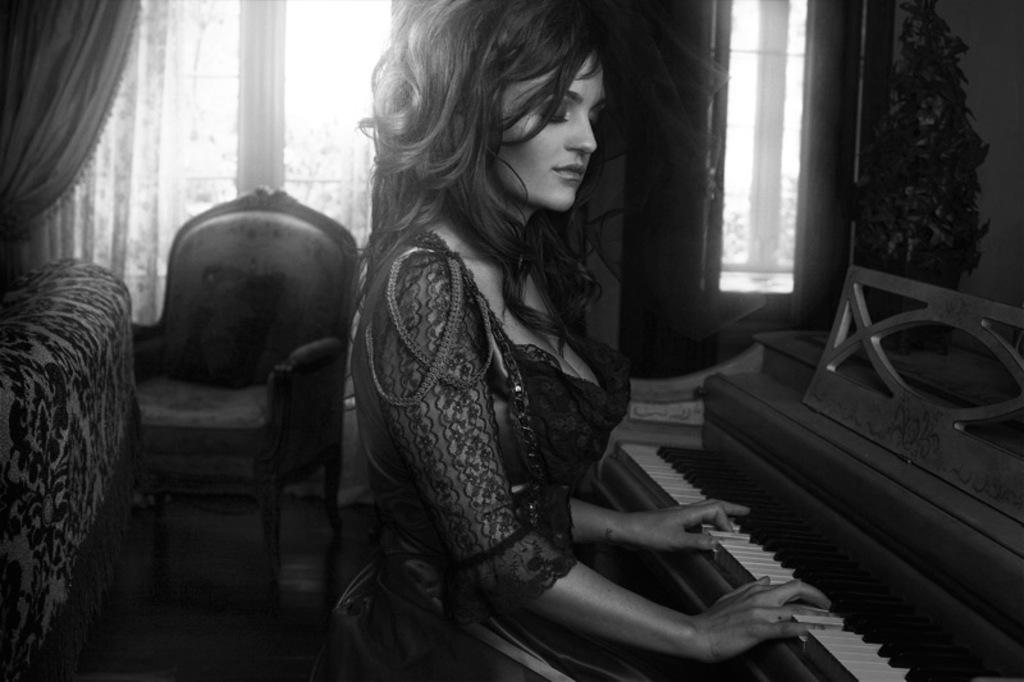Who is the main subject in the image? There is a girl in the image. What is the girl doing in the image? The girl is playing the piano. Where is the piano located in relation to the girl? The piano is in front of the girl. What can be seen in the background of the image? There is a chair and a window in the background of the image. What type of window treatment is present in the image? There is a curtain associated with the window. What type of trail can be seen in the image? There is no trail present in the image; it features a girl playing the piano. What kind of railway is visible in the image? There is no railway present in the image; it features a girl playing the piano. 